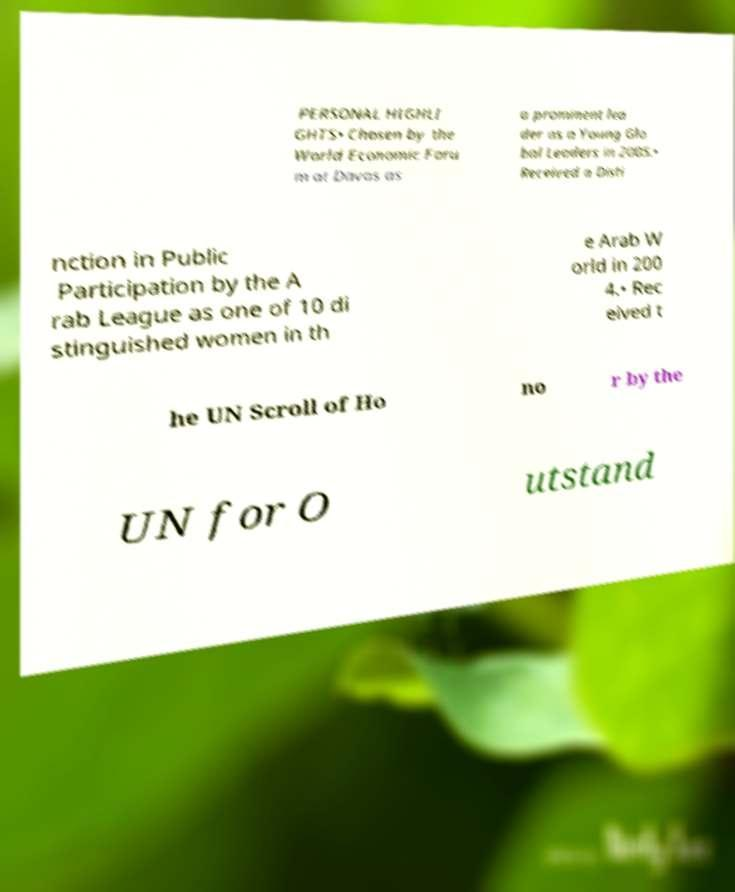Could you extract and type out the text from this image? PERSONAL HIGHLI GHTS• Chosen by the World Economic Foru m at Davos as a prominent lea der as a Young Glo bal Leaders in 2005.• Received a Disti nction in Public Participation by the A rab League as one of 10 di stinguished women in th e Arab W orld in 200 4.• Rec eived t he UN Scroll of Ho no r by the UN for O utstand 